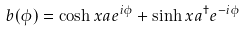<formula> <loc_0><loc_0><loc_500><loc_500>b ( \phi ) = \cosh x a e ^ { i \phi } + \sinh x a ^ { \dagger } e ^ { - i \phi }</formula> 